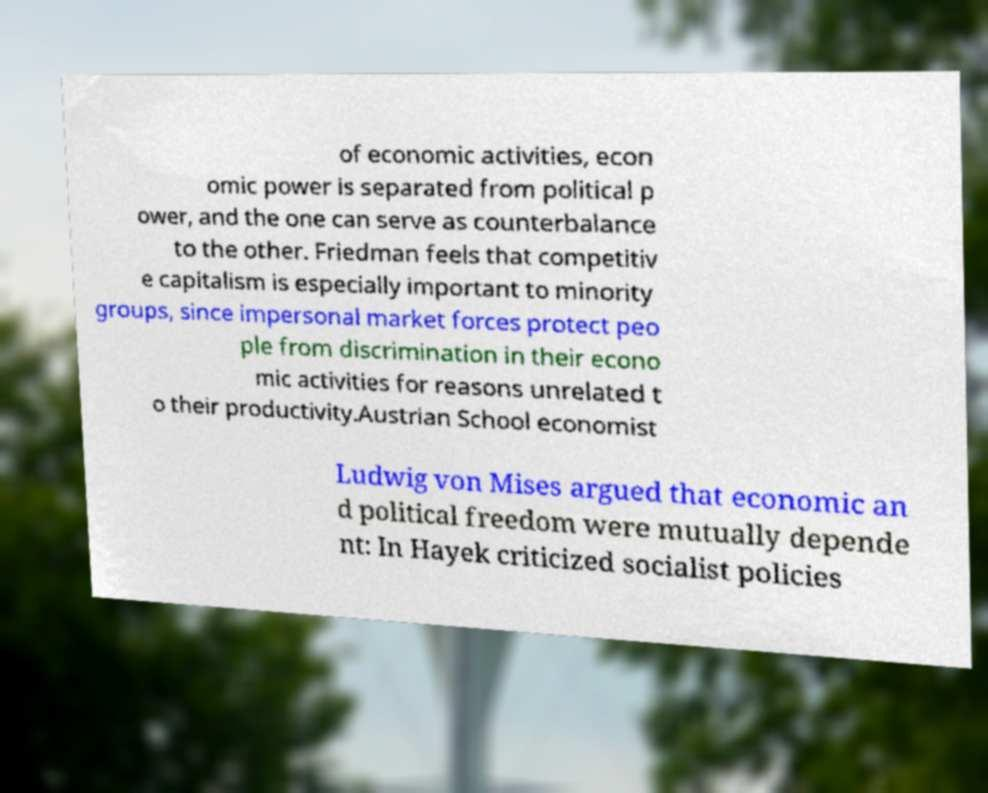Please identify and transcribe the text found in this image. of economic activities, econ omic power is separated from political p ower, and the one can serve as counterbalance to the other. Friedman feels that competitiv e capitalism is especially important to minority groups, since impersonal market forces protect peo ple from discrimination in their econo mic activities for reasons unrelated t o their productivity.Austrian School economist Ludwig von Mises argued that economic an d political freedom were mutually depende nt: In Hayek criticized socialist policies 